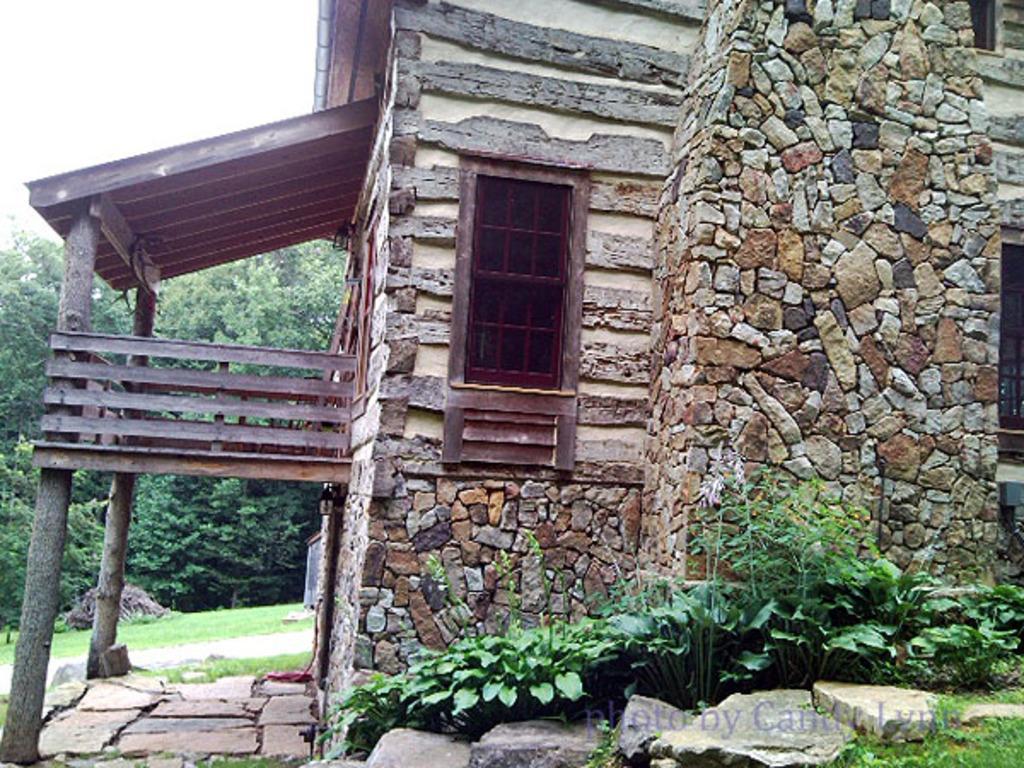Could you give a brief overview of what you see in this image? In this image in the center there is one house, and at the bottom there are some plants and some stones. And in the background there are some trees and grass, and at the top of the match there is sky. 